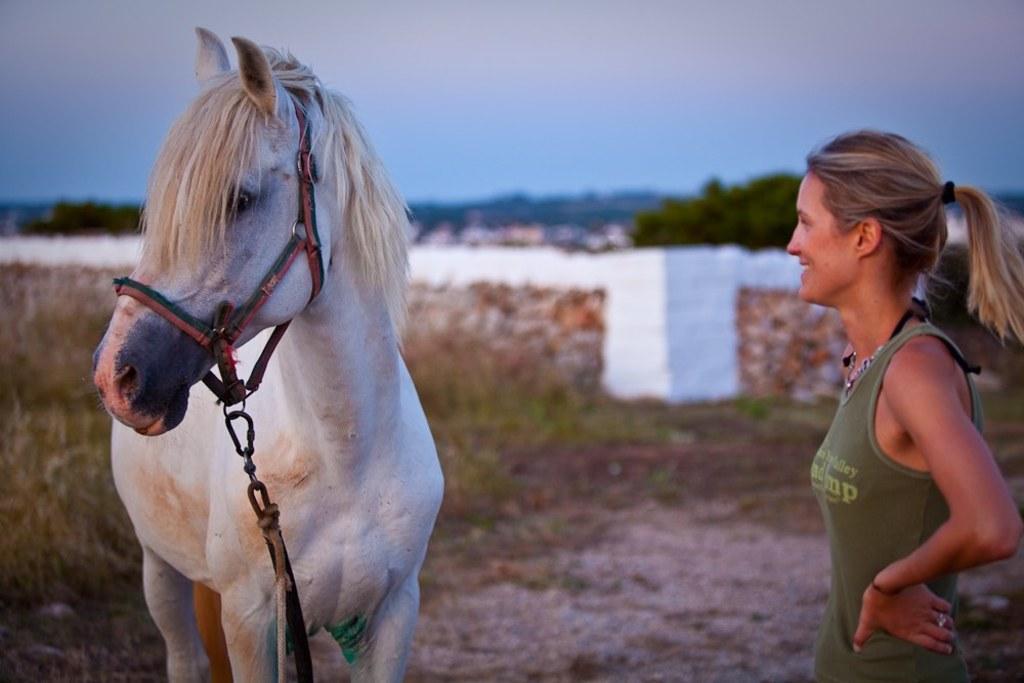Describe this image in one or two sentences. The woman on the right side is standing and she is smiling. On the left side, we see a white horse. At the bottom, we see the small stones, grass and shrubs. In the background, we see a white wall. There are trees, buildings and hills in the background. At the top, we see the sky. 